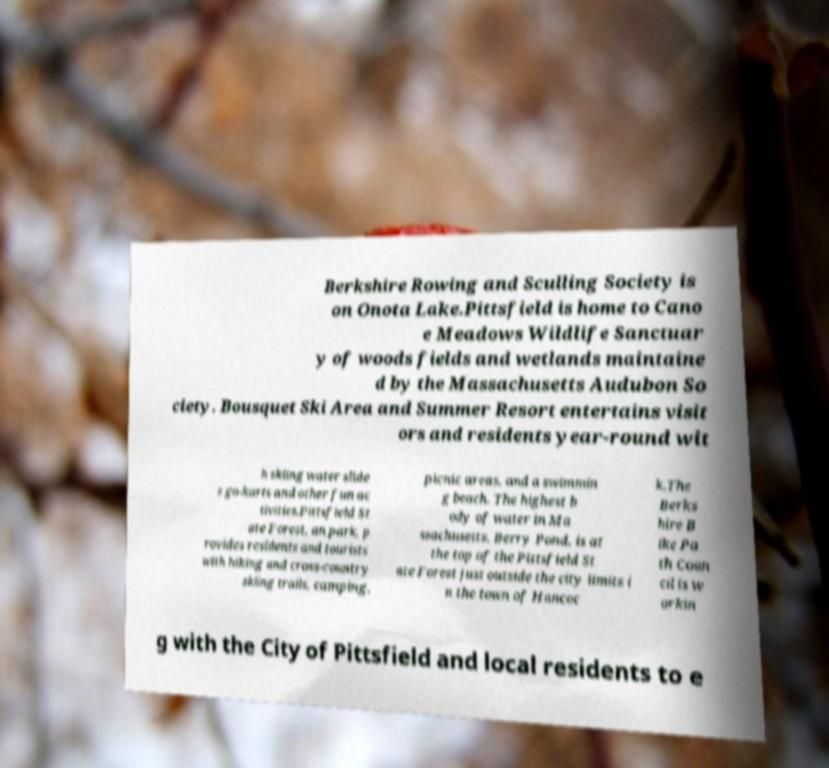I need the written content from this picture converted into text. Can you do that? Berkshire Rowing and Sculling Society is on Onota Lake.Pittsfield is home to Cano e Meadows Wildlife Sanctuar y of woods fields and wetlands maintaine d by the Massachusetts Audubon So ciety. Bousquet Ski Area and Summer Resort entertains visit ors and residents year-round wit h skiing water slide s go-karts and other fun ac tivities.Pittsfield St ate Forest, an park, p rovides residents and tourists with hiking and cross-country skiing trails, camping, picnic areas, and a swimmin g beach. The highest b ody of water in Ma ssachusetts, Berry Pond, is at the top of the Pittsfield St ate Forest just outside the city limits i n the town of Hancoc k.The Berks hire B ike Pa th Coun cil is w orkin g with the City of Pittsfield and local residents to e 